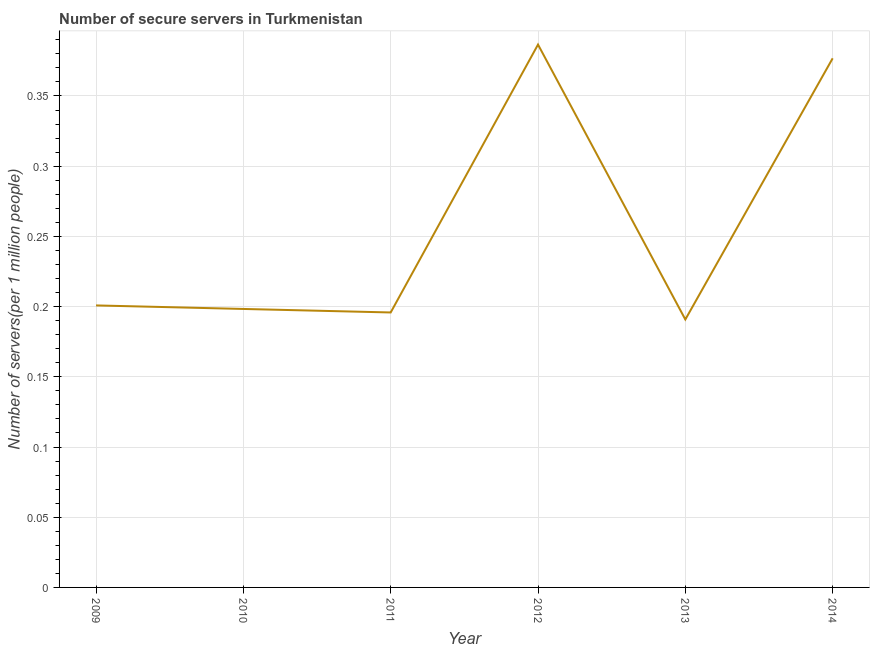What is the number of secure internet servers in 2014?
Provide a short and direct response. 0.38. Across all years, what is the maximum number of secure internet servers?
Provide a succinct answer. 0.39. Across all years, what is the minimum number of secure internet servers?
Keep it short and to the point. 0.19. In which year was the number of secure internet servers maximum?
Ensure brevity in your answer.  2012. In which year was the number of secure internet servers minimum?
Offer a terse response. 2013. What is the sum of the number of secure internet servers?
Offer a very short reply. 1.55. What is the difference between the number of secure internet servers in 2013 and 2014?
Provide a succinct answer. -0.19. What is the average number of secure internet servers per year?
Your response must be concise. 0.26. What is the median number of secure internet servers?
Ensure brevity in your answer.  0.2. In how many years, is the number of secure internet servers greater than 0.27 ?
Offer a very short reply. 2. What is the ratio of the number of secure internet servers in 2011 to that in 2014?
Make the answer very short. 0.52. Is the number of secure internet servers in 2009 less than that in 2013?
Keep it short and to the point. No. What is the difference between the highest and the second highest number of secure internet servers?
Keep it short and to the point. 0.01. Is the sum of the number of secure internet servers in 2009 and 2013 greater than the maximum number of secure internet servers across all years?
Offer a very short reply. Yes. What is the difference between the highest and the lowest number of secure internet servers?
Give a very brief answer. 0.2. Does the number of secure internet servers monotonically increase over the years?
Ensure brevity in your answer.  No. How many years are there in the graph?
Your answer should be compact. 6. What is the difference between two consecutive major ticks on the Y-axis?
Make the answer very short. 0.05. What is the title of the graph?
Make the answer very short. Number of secure servers in Turkmenistan. What is the label or title of the Y-axis?
Provide a succinct answer. Number of servers(per 1 million people). What is the Number of servers(per 1 million people) of 2009?
Offer a terse response. 0.2. What is the Number of servers(per 1 million people) in 2010?
Your response must be concise. 0.2. What is the Number of servers(per 1 million people) of 2011?
Your answer should be compact. 0.2. What is the Number of servers(per 1 million people) of 2012?
Provide a short and direct response. 0.39. What is the Number of servers(per 1 million people) in 2013?
Keep it short and to the point. 0.19. What is the Number of servers(per 1 million people) in 2014?
Offer a very short reply. 0.38. What is the difference between the Number of servers(per 1 million people) in 2009 and 2010?
Your answer should be compact. 0. What is the difference between the Number of servers(per 1 million people) in 2009 and 2011?
Your response must be concise. 0.01. What is the difference between the Number of servers(per 1 million people) in 2009 and 2012?
Make the answer very short. -0.19. What is the difference between the Number of servers(per 1 million people) in 2009 and 2013?
Your response must be concise. 0.01. What is the difference between the Number of servers(per 1 million people) in 2009 and 2014?
Make the answer very short. -0.18. What is the difference between the Number of servers(per 1 million people) in 2010 and 2011?
Give a very brief answer. 0. What is the difference between the Number of servers(per 1 million people) in 2010 and 2012?
Your response must be concise. -0.19. What is the difference between the Number of servers(per 1 million people) in 2010 and 2013?
Ensure brevity in your answer.  0.01. What is the difference between the Number of servers(per 1 million people) in 2010 and 2014?
Offer a terse response. -0.18. What is the difference between the Number of servers(per 1 million people) in 2011 and 2012?
Keep it short and to the point. -0.19. What is the difference between the Number of servers(per 1 million people) in 2011 and 2013?
Offer a very short reply. 0. What is the difference between the Number of servers(per 1 million people) in 2011 and 2014?
Make the answer very short. -0.18. What is the difference between the Number of servers(per 1 million people) in 2012 and 2013?
Keep it short and to the point. 0.2. What is the difference between the Number of servers(per 1 million people) in 2012 and 2014?
Provide a short and direct response. 0.01. What is the difference between the Number of servers(per 1 million people) in 2013 and 2014?
Your response must be concise. -0.19. What is the ratio of the Number of servers(per 1 million people) in 2009 to that in 2010?
Your answer should be very brief. 1.01. What is the ratio of the Number of servers(per 1 million people) in 2009 to that in 2011?
Your answer should be compact. 1.03. What is the ratio of the Number of servers(per 1 million people) in 2009 to that in 2012?
Keep it short and to the point. 0.52. What is the ratio of the Number of servers(per 1 million people) in 2009 to that in 2013?
Give a very brief answer. 1.05. What is the ratio of the Number of servers(per 1 million people) in 2009 to that in 2014?
Keep it short and to the point. 0.53. What is the ratio of the Number of servers(per 1 million people) in 2010 to that in 2012?
Make the answer very short. 0.51. What is the ratio of the Number of servers(per 1 million people) in 2010 to that in 2013?
Ensure brevity in your answer.  1.04. What is the ratio of the Number of servers(per 1 million people) in 2010 to that in 2014?
Provide a short and direct response. 0.53. What is the ratio of the Number of servers(per 1 million people) in 2011 to that in 2012?
Give a very brief answer. 0.51. What is the ratio of the Number of servers(per 1 million people) in 2011 to that in 2013?
Keep it short and to the point. 1.03. What is the ratio of the Number of servers(per 1 million people) in 2011 to that in 2014?
Offer a very short reply. 0.52. What is the ratio of the Number of servers(per 1 million people) in 2012 to that in 2013?
Provide a short and direct response. 2.03. What is the ratio of the Number of servers(per 1 million people) in 2012 to that in 2014?
Your response must be concise. 1.03. What is the ratio of the Number of servers(per 1 million people) in 2013 to that in 2014?
Provide a succinct answer. 0.51. 